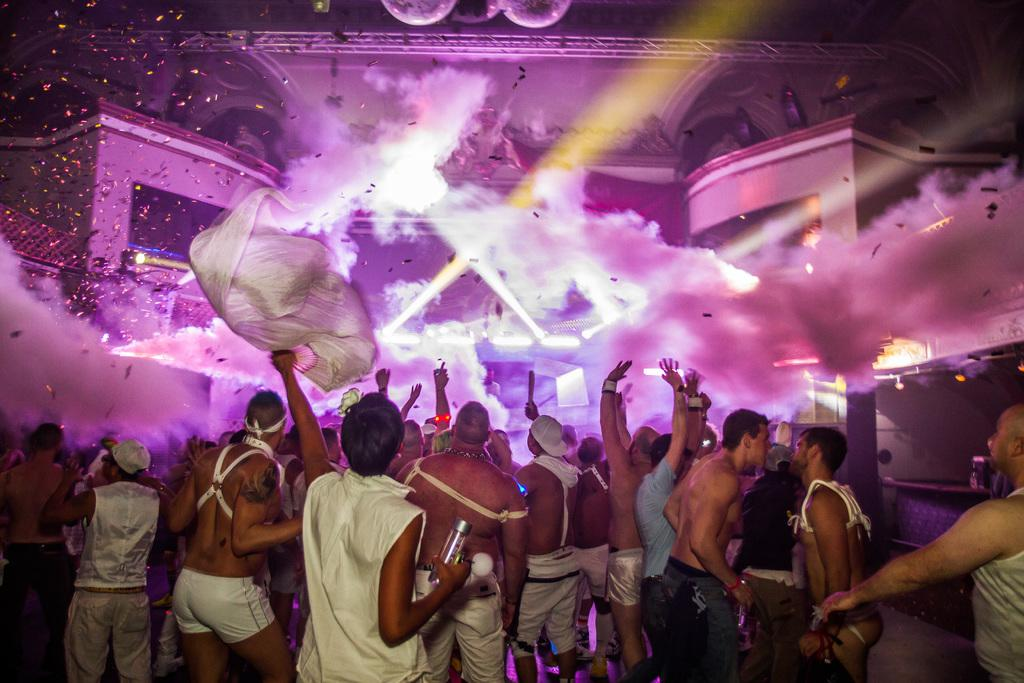How many people are in the image? There are many people in the image. Where are the people located in the image? The people are in the front of the image. What are the people wearing in the image? The people are wearing white dresses. What are the people doing in the image? The people are dancing. What can be seen in the background of the image? There is a building and purple smoke in the background of the image. What is special about the building in the background? The building has lights. Who is the creator of the base in the image? There is no base present in the image, so it is not possible to determine who created it. 